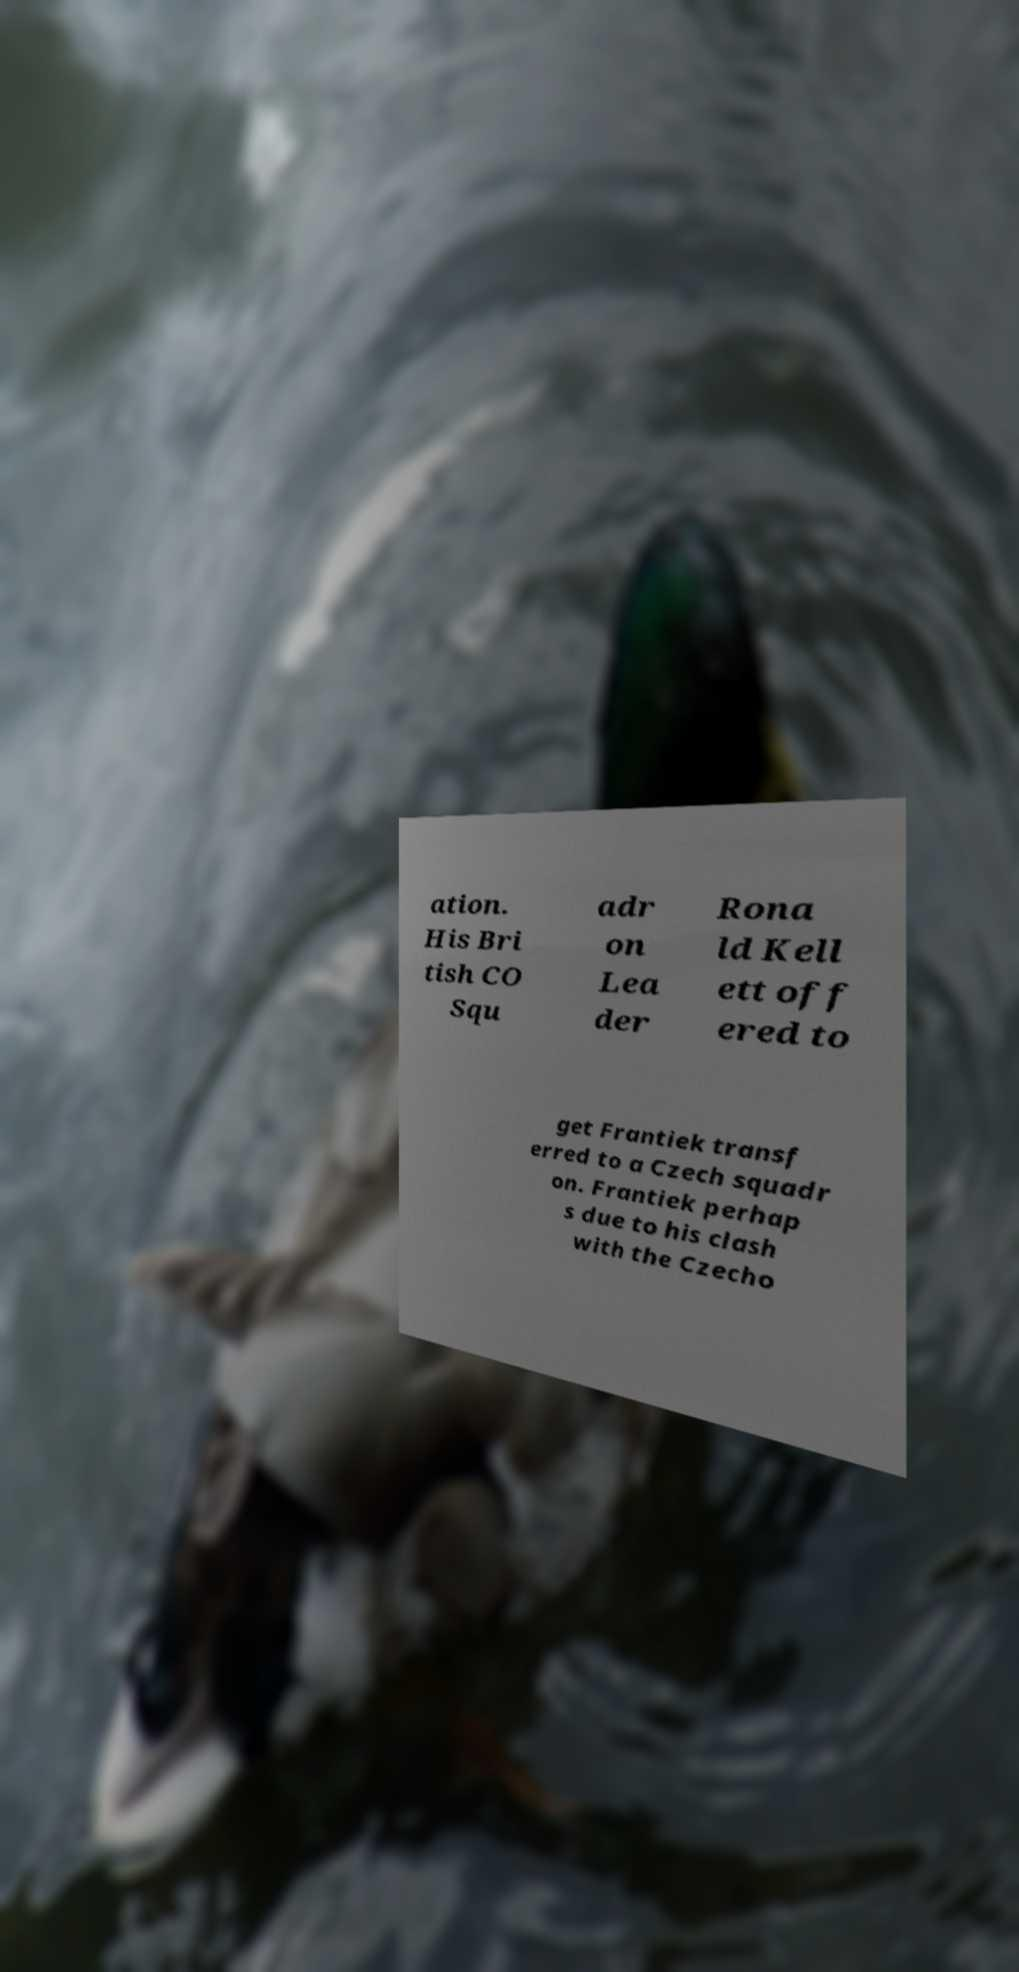For documentation purposes, I need the text within this image transcribed. Could you provide that? ation. His Bri tish CO Squ adr on Lea der Rona ld Kell ett off ered to get Frantiek transf erred to a Czech squadr on. Frantiek perhap s due to his clash with the Czecho 